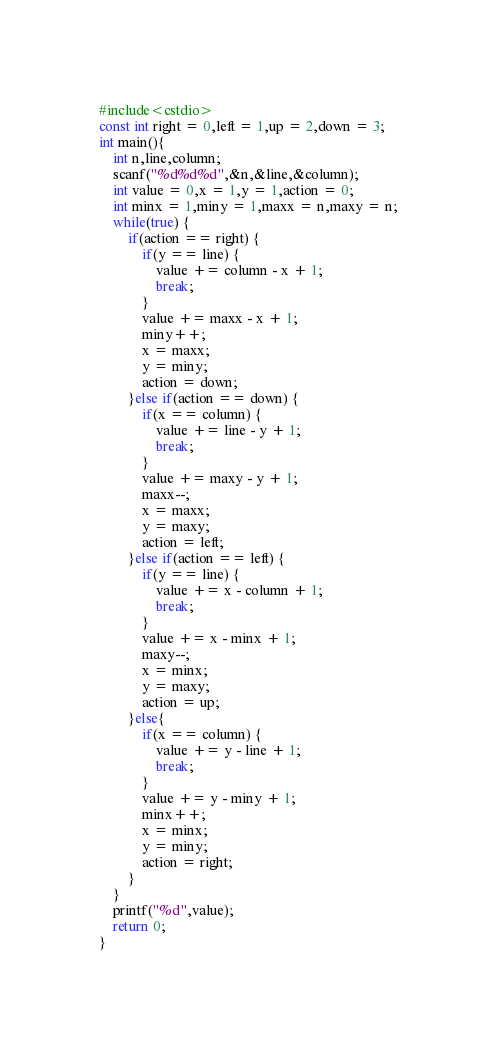Convert code to text. <code><loc_0><loc_0><loc_500><loc_500><_C++_>#include<cstdio>
const int right = 0,left = 1,up = 2,down = 3;
int main(){
	int n,line,column;
	scanf("%d%d%d",&n,&line,&column);
	int value = 0,x = 1,y = 1,action = 0;
	int minx = 1,miny = 1,maxx = n,maxy = n;
	while(true) {
		if(action == right) {
			if(y == line) {
				value += column - x + 1;
				break;
			}
			value += maxx - x + 1;
			miny++;
			x = maxx;
			y = miny;
			action = down;
		}else if(action == down) {
			if(x == column) {
				value += line - y + 1;
				break;
			}
			value += maxy - y + 1;
			maxx--;
			x = maxx;
			y = maxy;
			action = left;
		}else if(action == left) {
			if(y == line) {
				value += x - column + 1;
				break;
			}
			value += x - minx + 1;
			maxy--;
			x = minx;
			y = maxy;
			action = up;
		}else{
			if(x == column) {
				value += y - line + 1;
				break;
			}
			value += y - miny + 1;
			minx++;
			x = minx;
			y = miny;
			action = right;
		}
	}
	printf("%d",value);
    return 0;
}
</code> 